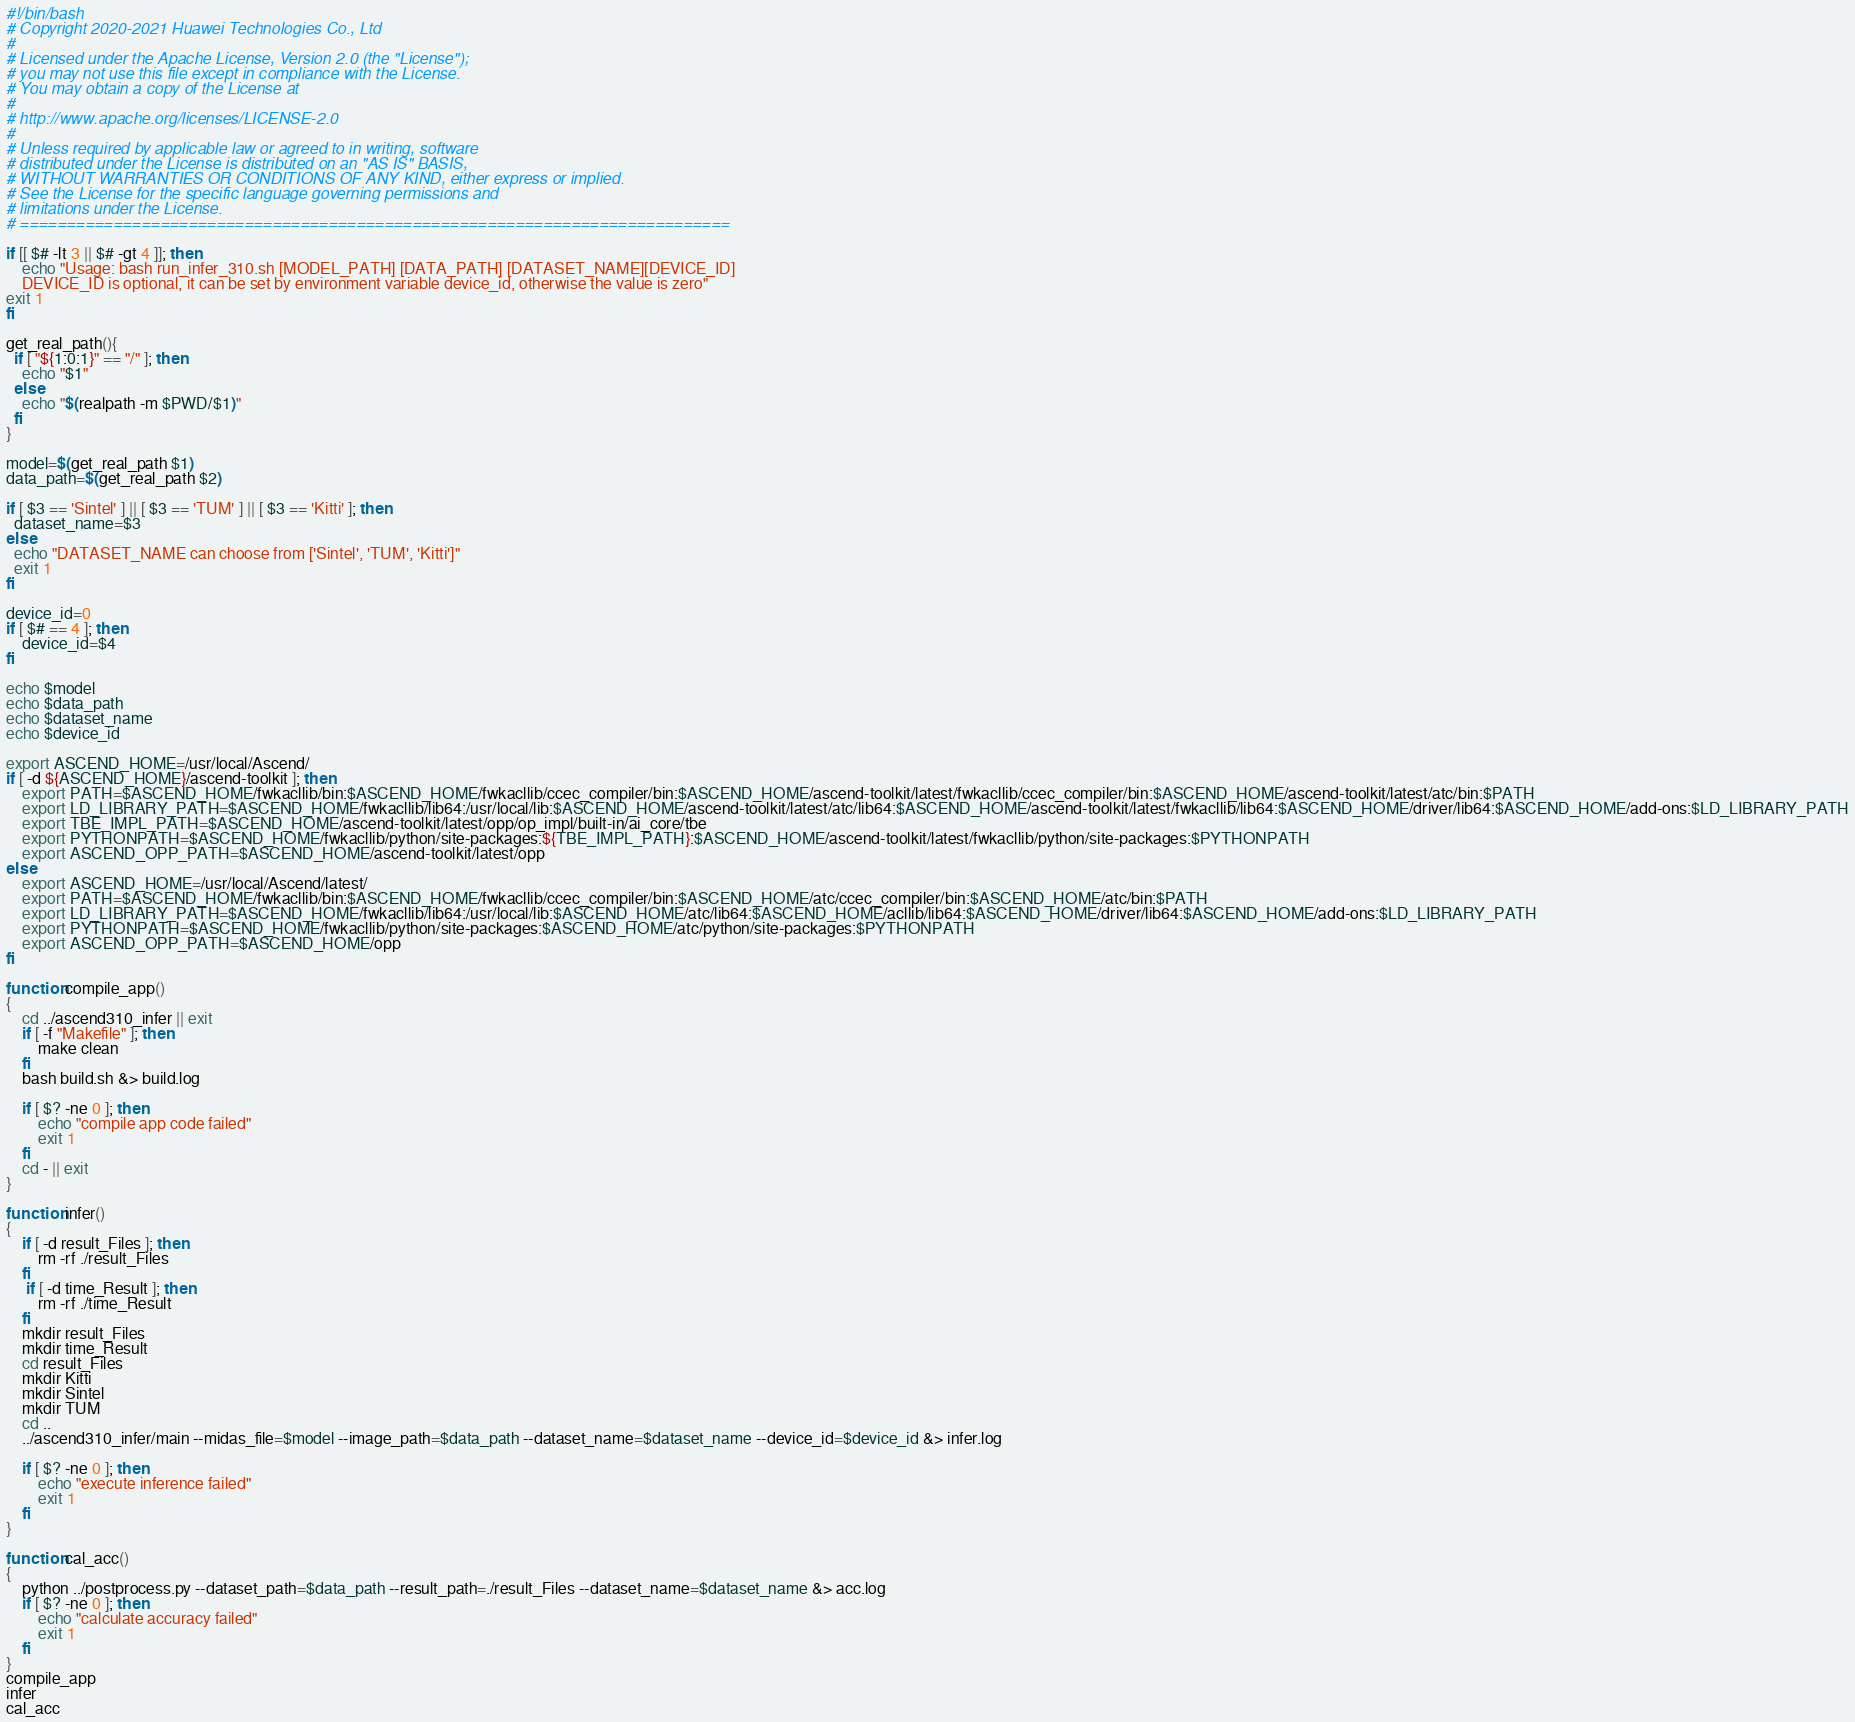Convert code to text. <code><loc_0><loc_0><loc_500><loc_500><_Bash_>#!/bin/bash
# Copyright 2020-2021 Huawei Technologies Co., Ltd
#
# Licensed under the Apache License, Version 2.0 (the "License");
# you may not use this file except in compliance with the License.
# You may obtain a copy of the License at
#
# http://www.apache.org/licenses/LICENSE-2.0
#
# Unless required by applicable law or agreed to in writing, software
# distributed under the License is distributed on an "AS IS" BASIS,
# WITHOUT WARRANTIES OR CONDITIONS OF ANY KIND, either express or implied.
# See the License for the specific language governing permissions and
# limitations under the License.
# ============================================================================

if [[ $# -lt 3 || $# -gt 4 ]]; then 
    echo "Usage: bash run_infer_310.sh [MODEL_PATH] [DATA_PATH] [DATASET_NAME][DEVICE_ID]
    DEVICE_ID is optional, it can be set by environment variable device_id, otherwise the value is zero"
exit 1
fi

get_real_path(){
  if [ "${1:0:1}" == "/" ]; then
    echo "$1"
  else
    echo "$(realpath -m $PWD/$1)"
  fi
}

model=$(get_real_path $1)
data_path=$(get_real_path $2)

if [ $3 == 'Sintel' ] || [ $3 == 'TUM' ] || [ $3 == 'Kitti' ]; then
  dataset_name=$3
else
  echo "DATASET_NAME can choose from ['Sintel', 'TUM', 'Kitti']"
  exit 1
fi

device_id=0
if [ $# == 4 ]; then
    device_id=$4
fi

echo $model
echo $data_path
echo $dataset_name
echo $device_id

export ASCEND_HOME=/usr/local/Ascend/
if [ -d ${ASCEND_HOME}/ascend-toolkit ]; then
    export PATH=$ASCEND_HOME/fwkacllib/bin:$ASCEND_HOME/fwkacllib/ccec_compiler/bin:$ASCEND_HOME/ascend-toolkit/latest/fwkacllib/ccec_compiler/bin:$ASCEND_HOME/ascend-toolkit/latest/atc/bin:$PATH
    export LD_LIBRARY_PATH=$ASCEND_HOME/fwkacllib/lib64:/usr/local/lib:$ASCEND_HOME/ascend-toolkit/latest/atc/lib64:$ASCEND_HOME/ascend-toolkit/latest/fwkacllib/lib64:$ASCEND_HOME/driver/lib64:$ASCEND_HOME/add-ons:$LD_LIBRARY_PATH
    export TBE_IMPL_PATH=$ASCEND_HOME/ascend-toolkit/latest/opp/op_impl/built-in/ai_core/tbe
    export PYTHONPATH=$ASCEND_HOME/fwkacllib/python/site-packages:${TBE_IMPL_PATH}:$ASCEND_HOME/ascend-toolkit/latest/fwkacllib/python/site-packages:$PYTHONPATH
    export ASCEND_OPP_PATH=$ASCEND_HOME/ascend-toolkit/latest/opp
else
    export ASCEND_HOME=/usr/local/Ascend/latest/
    export PATH=$ASCEND_HOME/fwkacllib/bin:$ASCEND_HOME/fwkacllib/ccec_compiler/bin:$ASCEND_HOME/atc/ccec_compiler/bin:$ASCEND_HOME/atc/bin:$PATH
    export LD_LIBRARY_PATH=$ASCEND_HOME/fwkacllib/lib64:/usr/local/lib:$ASCEND_HOME/atc/lib64:$ASCEND_HOME/acllib/lib64:$ASCEND_HOME/driver/lib64:$ASCEND_HOME/add-ons:$LD_LIBRARY_PATH
    export PYTHONPATH=$ASCEND_HOME/fwkacllib/python/site-packages:$ASCEND_HOME/atc/python/site-packages:$PYTHONPATH
    export ASCEND_OPP_PATH=$ASCEND_HOME/opp
fi

function compile_app()
{
    cd ../ascend310_infer || exit
    if [ -f "Makefile" ]; then
        make clean
    fi
    bash build.sh &> build.log

    if [ $? -ne 0 ]; then
        echo "compile app code failed"
        exit 1
    fi
    cd - || exit
}

function infer()
{
    if [ -d result_Files ]; then
        rm -rf ./result_Files
    fi
     if [ -d time_Result ]; then
        rm -rf ./time_Result
    fi
    mkdir result_Files
    mkdir time_Result
    cd result_Files
    mkdir Kitti
    mkdir Sintel
    mkdir TUM
    cd ..
    ../ascend310_infer/main --midas_file=$model --image_path=$data_path --dataset_name=$dataset_name --device_id=$device_id &> infer.log

    if [ $? -ne 0 ]; then
        echo "execute inference failed"
        exit 1
    fi
}

function cal_acc()
{
    python ../postprocess.py --dataset_path=$data_path --result_path=./result_Files --dataset_name=$dataset_name &> acc.log
    if [ $? -ne 0 ]; then
        echo "calculate accuracy failed"
        exit 1
    fi
}
compile_app
infer
cal_acc
</code> 